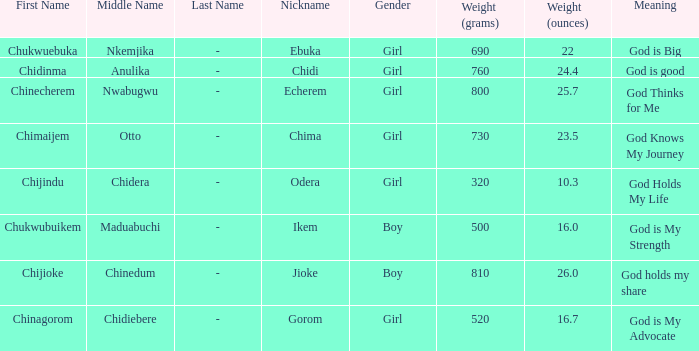What is the nickname of the boy who weighed 810g (26.0 oz.) at birth? Jioke. Help me parse the entirety of this table. {'header': ['First Name', 'Middle Name', 'Last Name', 'Nickname', 'Gender', 'Weight (grams)', 'Weight (ounces)', 'Meaning'], 'rows': [['Chukwuebuka', 'Nkemjika', '-', 'Ebuka', 'Girl', '690', '22', 'God is Big'], ['Chidinma', 'Anulika', '-', 'Chidi', 'Girl', '760', '24.4', 'God is good'], ['Chinecherem', 'Nwabugwu', '-', 'Echerem', 'Girl', '800', '25.7', 'God Thinks for Me'], ['Chimaijem', 'Otto', '-', 'Chima', 'Girl', '730', '23.5', 'God Knows My Journey'], ['Chijindu', 'Chidera', '-', 'Odera', 'Girl', '320', '10.3', 'God Holds My Life'], ['Chukwubuikem', 'Maduabuchi', '-', 'Ikem', 'Boy', '500', '16.0', 'God is My Strength'], ['Chijioke', 'Chinedum', '-', 'Jioke', 'Boy', '810', '26.0', 'God holds my share'], ['Chinagorom', 'Chidiebere', '-', 'Gorom', 'Girl', '520', '16.7', 'God is My Advocate']]} 